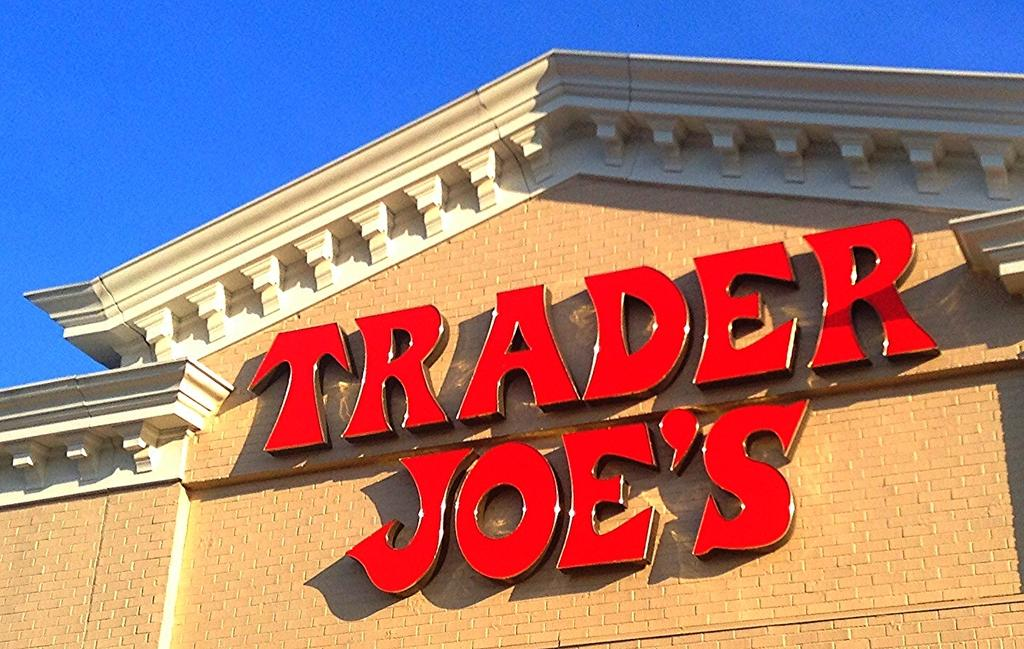What is the main subject of the image? There is a huge building in the image. What colors are used for the building? The building is brown and cream in color. Are there any additional features on the building? Yes, there are red-colored boards on the building. What can be seen in the background of the image? The sky is visible in the background of the image. What time does the watch on the building show in the image? There is no watch present on the building in the image. What type of spade is being used to dig near the building? There is no spade or digging activity depicted in the image. 